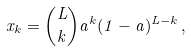Convert formula to latex. <formula><loc_0><loc_0><loc_500><loc_500>x _ { k } = \binom { L } { k } a ^ { k } ( 1 - a ) ^ { L - k } \, ,</formula> 